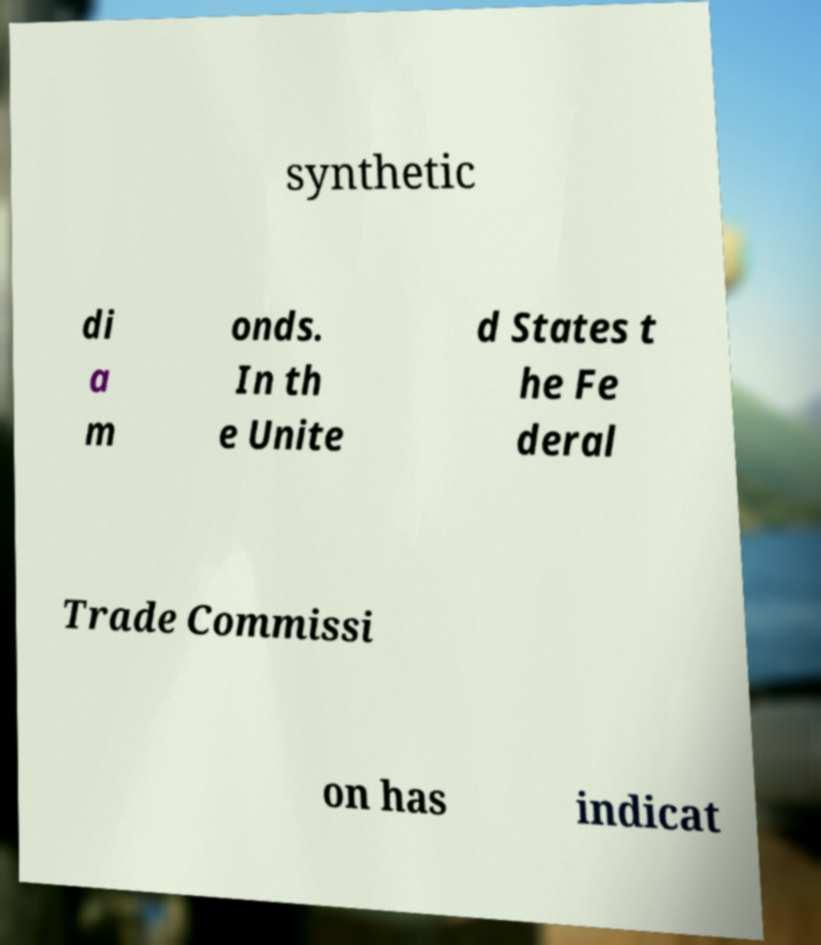Could you extract and type out the text from this image? synthetic di a m onds. In th e Unite d States t he Fe deral Trade Commissi on has indicat 